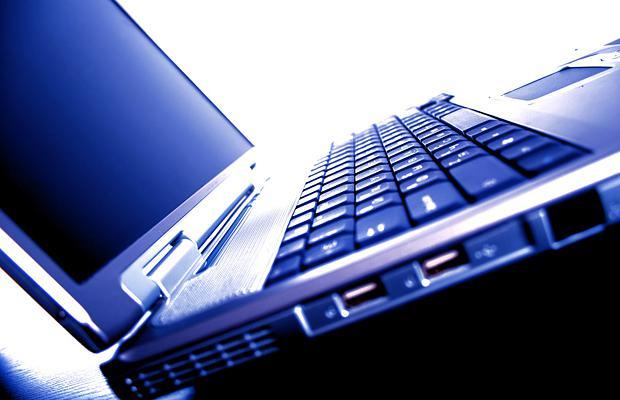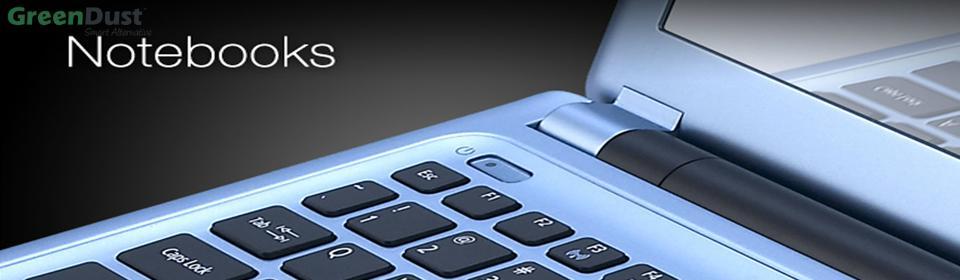The first image is the image on the left, the second image is the image on the right. For the images displayed, is the sentence "There are more than two laptops." factually correct? Answer yes or no. No. The first image is the image on the left, the second image is the image on the right. For the images shown, is this caption "One image includes at least one laptop with its open screen showing a blue nature-themed picture, and the other image contains one computer keyboard." true? Answer yes or no. No. 